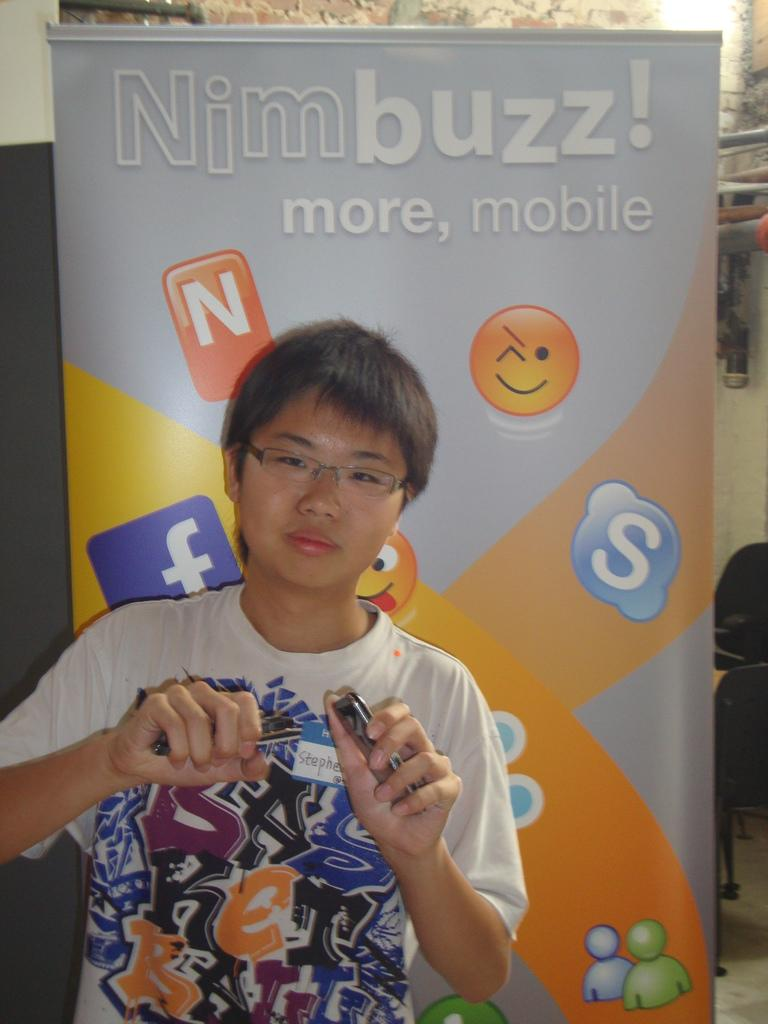Provide a one-sentence caption for the provided image. a person with the name Nim buzz on it. 